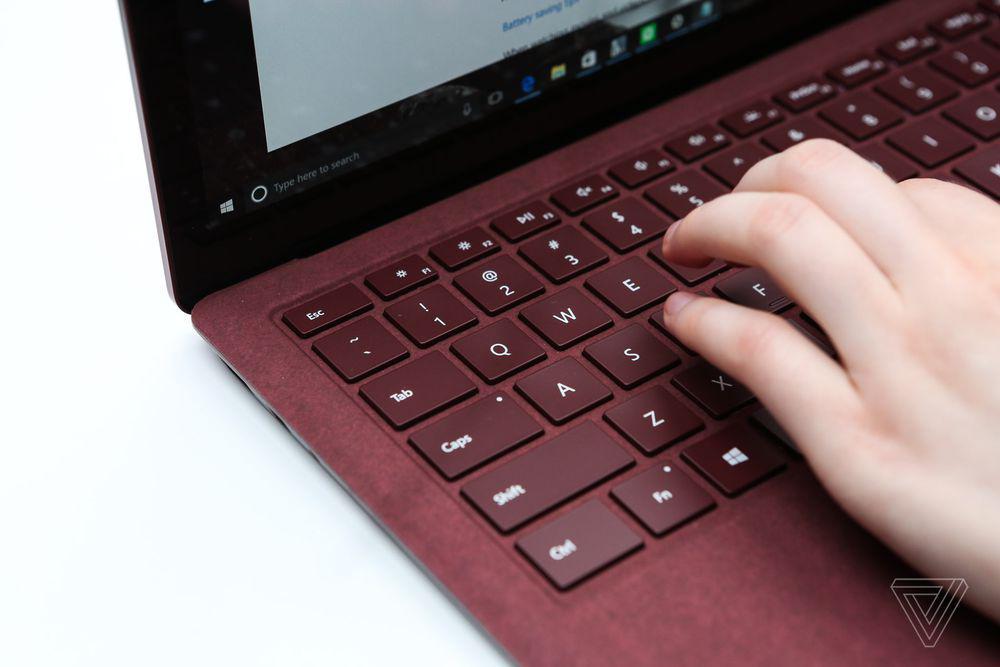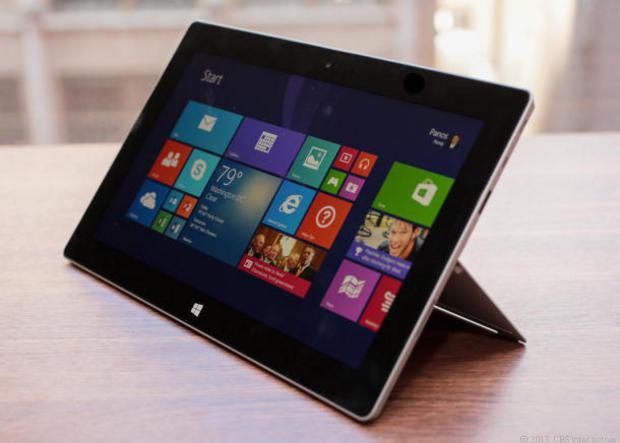The first image is the image on the left, the second image is the image on the right. Analyze the images presented: Is the assertion "One image shows a hand reaching for something plugged into the side of an open laptop." valid? Answer yes or no. No. The first image is the image on the left, the second image is the image on the right. Considering the images on both sides, is "In at least one image there is a black laptop that is open and turned right." valid? Answer yes or no. No. 